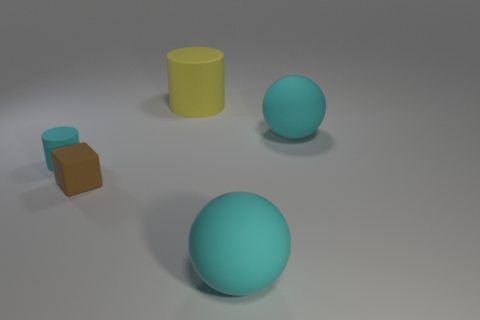Add 4 cyan rubber spheres. How many objects exist? 9 Subtract all cylinders. How many objects are left? 3 Subtract all cyan rubber things. Subtract all cyan spheres. How many objects are left? 0 Add 1 large cyan things. How many large cyan things are left? 3 Add 4 large gray matte things. How many large gray matte things exist? 4 Subtract 0 purple cylinders. How many objects are left? 5 